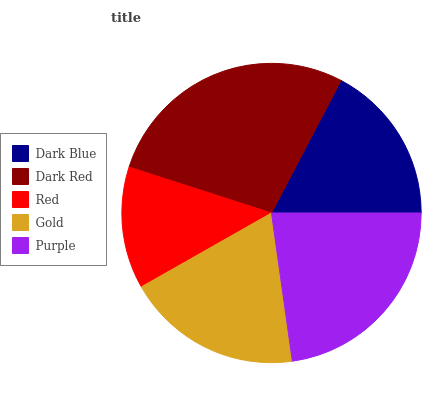Is Red the minimum?
Answer yes or no. Yes. Is Dark Red the maximum?
Answer yes or no. Yes. Is Dark Red the minimum?
Answer yes or no. No. Is Red the maximum?
Answer yes or no. No. Is Dark Red greater than Red?
Answer yes or no. Yes. Is Red less than Dark Red?
Answer yes or no. Yes. Is Red greater than Dark Red?
Answer yes or no. No. Is Dark Red less than Red?
Answer yes or no. No. Is Gold the high median?
Answer yes or no. Yes. Is Gold the low median?
Answer yes or no. Yes. Is Dark Blue the high median?
Answer yes or no. No. Is Dark Red the low median?
Answer yes or no. No. 